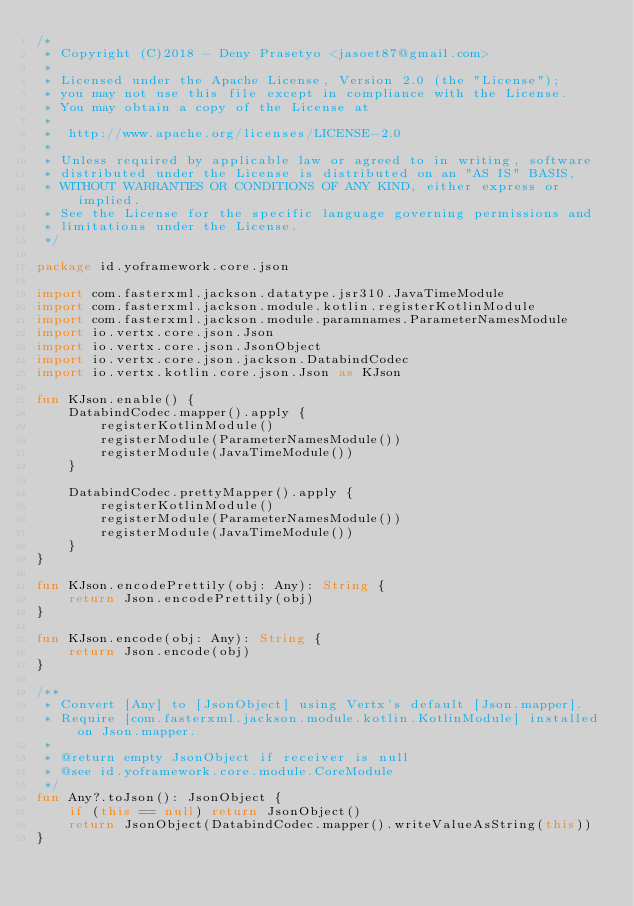<code> <loc_0><loc_0><loc_500><loc_500><_Kotlin_>/*
 * Copyright (C)2018 - Deny Prasetyo <jasoet87@gmail.com>
 *
 * Licensed under the Apache License, Version 2.0 (the "License");
 * you may not use this file except in compliance with the License.
 * You may obtain a copy of the License at
 *
 *  http://www.apache.org/licenses/LICENSE-2.0
 *
 * Unless required by applicable law or agreed to in writing, software
 * distributed under the License is distributed on an "AS IS" BASIS,
 * WITHOUT WARRANTIES OR CONDITIONS OF ANY KIND, either express or implied.
 * See the License for the specific language governing permissions and
 * limitations under the License.
 */

package id.yoframework.core.json

import com.fasterxml.jackson.datatype.jsr310.JavaTimeModule
import com.fasterxml.jackson.module.kotlin.registerKotlinModule
import com.fasterxml.jackson.module.paramnames.ParameterNamesModule
import io.vertx.core.json.Json
import io.vertx.core.json.JsonObject
import io.vertx.core.json.jackson.DatabindCodec
import io.vertx.kotlin.core.json.Json as KJson

fun KJson.enable() {
    DatabindCodec.mapper().apply {
        registerKotlinModule()
        registerModule(ParameterNamesModule())
        registerModule(JavaTimeModule())
    }

    DatabindCodec.prettyMapper().apply {
        registerKotlinModule()
        registerModule(ParameterNamesModule())
        registerModule(JavaTimeModule())
    }
}

fun KJson.encodePrettily(obj: Any): String {
    return Json.encodePrettily(obj)
}

fun KJson.encode(obj: Any): String {
    return Json.encode(obj)
}

/**
 * Convert [Any] to [JsonObject] using Vertx's default [Json.mapper].
 * Require [com.fasterxml.jackson.module.kotlin.KotlinModule] installed on Json.mapper.
 *
 * @return empty JsonObject if receiver is null
 * @see id.yoframework.core.module.CoreModule
 */
fun Any?.toJson(): JsonObject {
    if (this == null) return JsonObject()
    return JsonObject(DatabindCodec.mapper().writeValueAsString(this))
}
</code> 